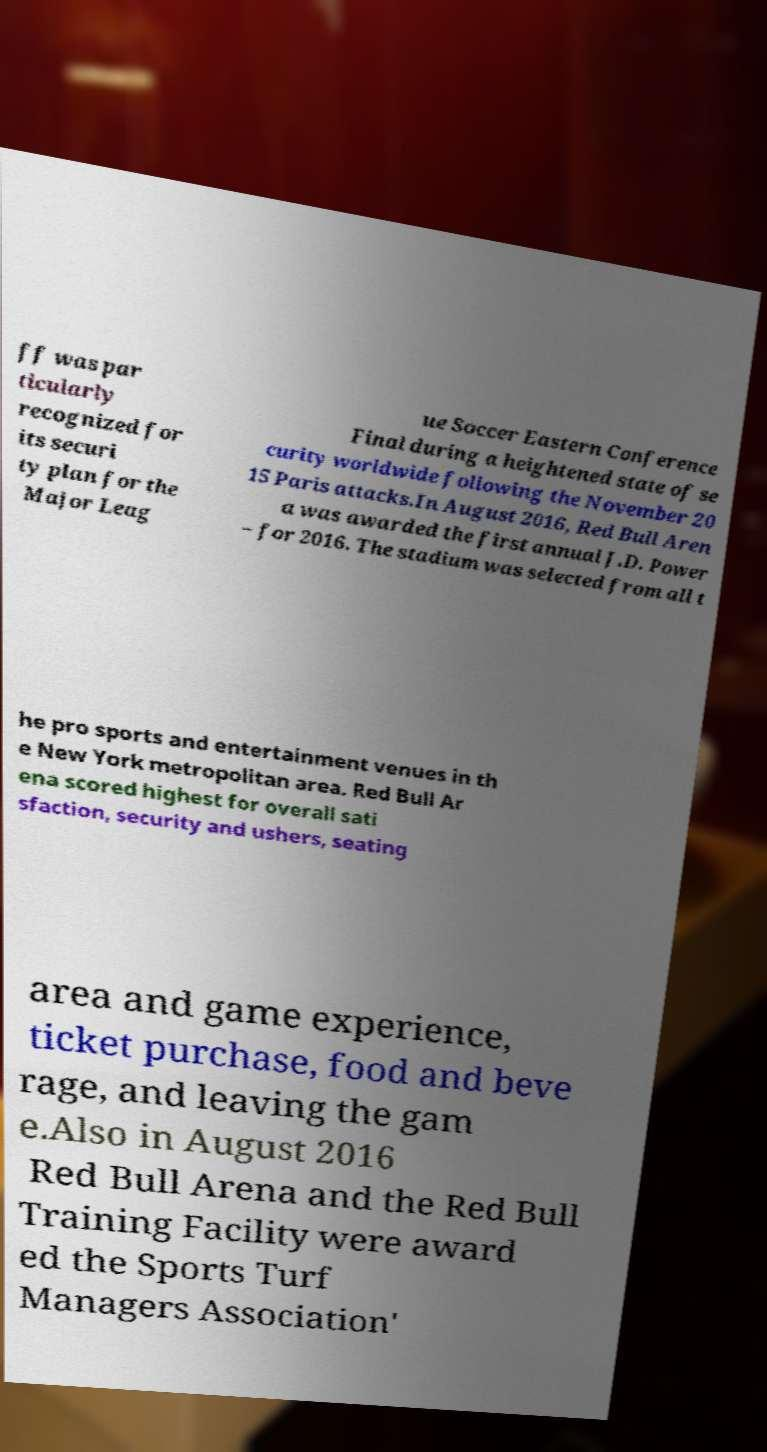Could you extract and type out the text from this image? ff was par ticularly recognized for its securi ty plan for the Major Leag ue Soccer Eastern Conference Final during a heightened state of se curity worldwide following the November 20 15 Paris attacks.In August 2016, Red Bull Aren a was awarded the first annual J.D. Power – for 2016. The stadium was selected from all t he pro sports and entertainment venues in th e New York metropolitan area. Red Bull Ar ena scored highest for overall sati sfaction, security and ushers, seating area and game experience, ticket purchase, food and beve rage, and leaving the gam e.Also in August 2016 Red Bull Arena and the Red Bull Training Facility were award ed the Sports Turf Managers Association' 